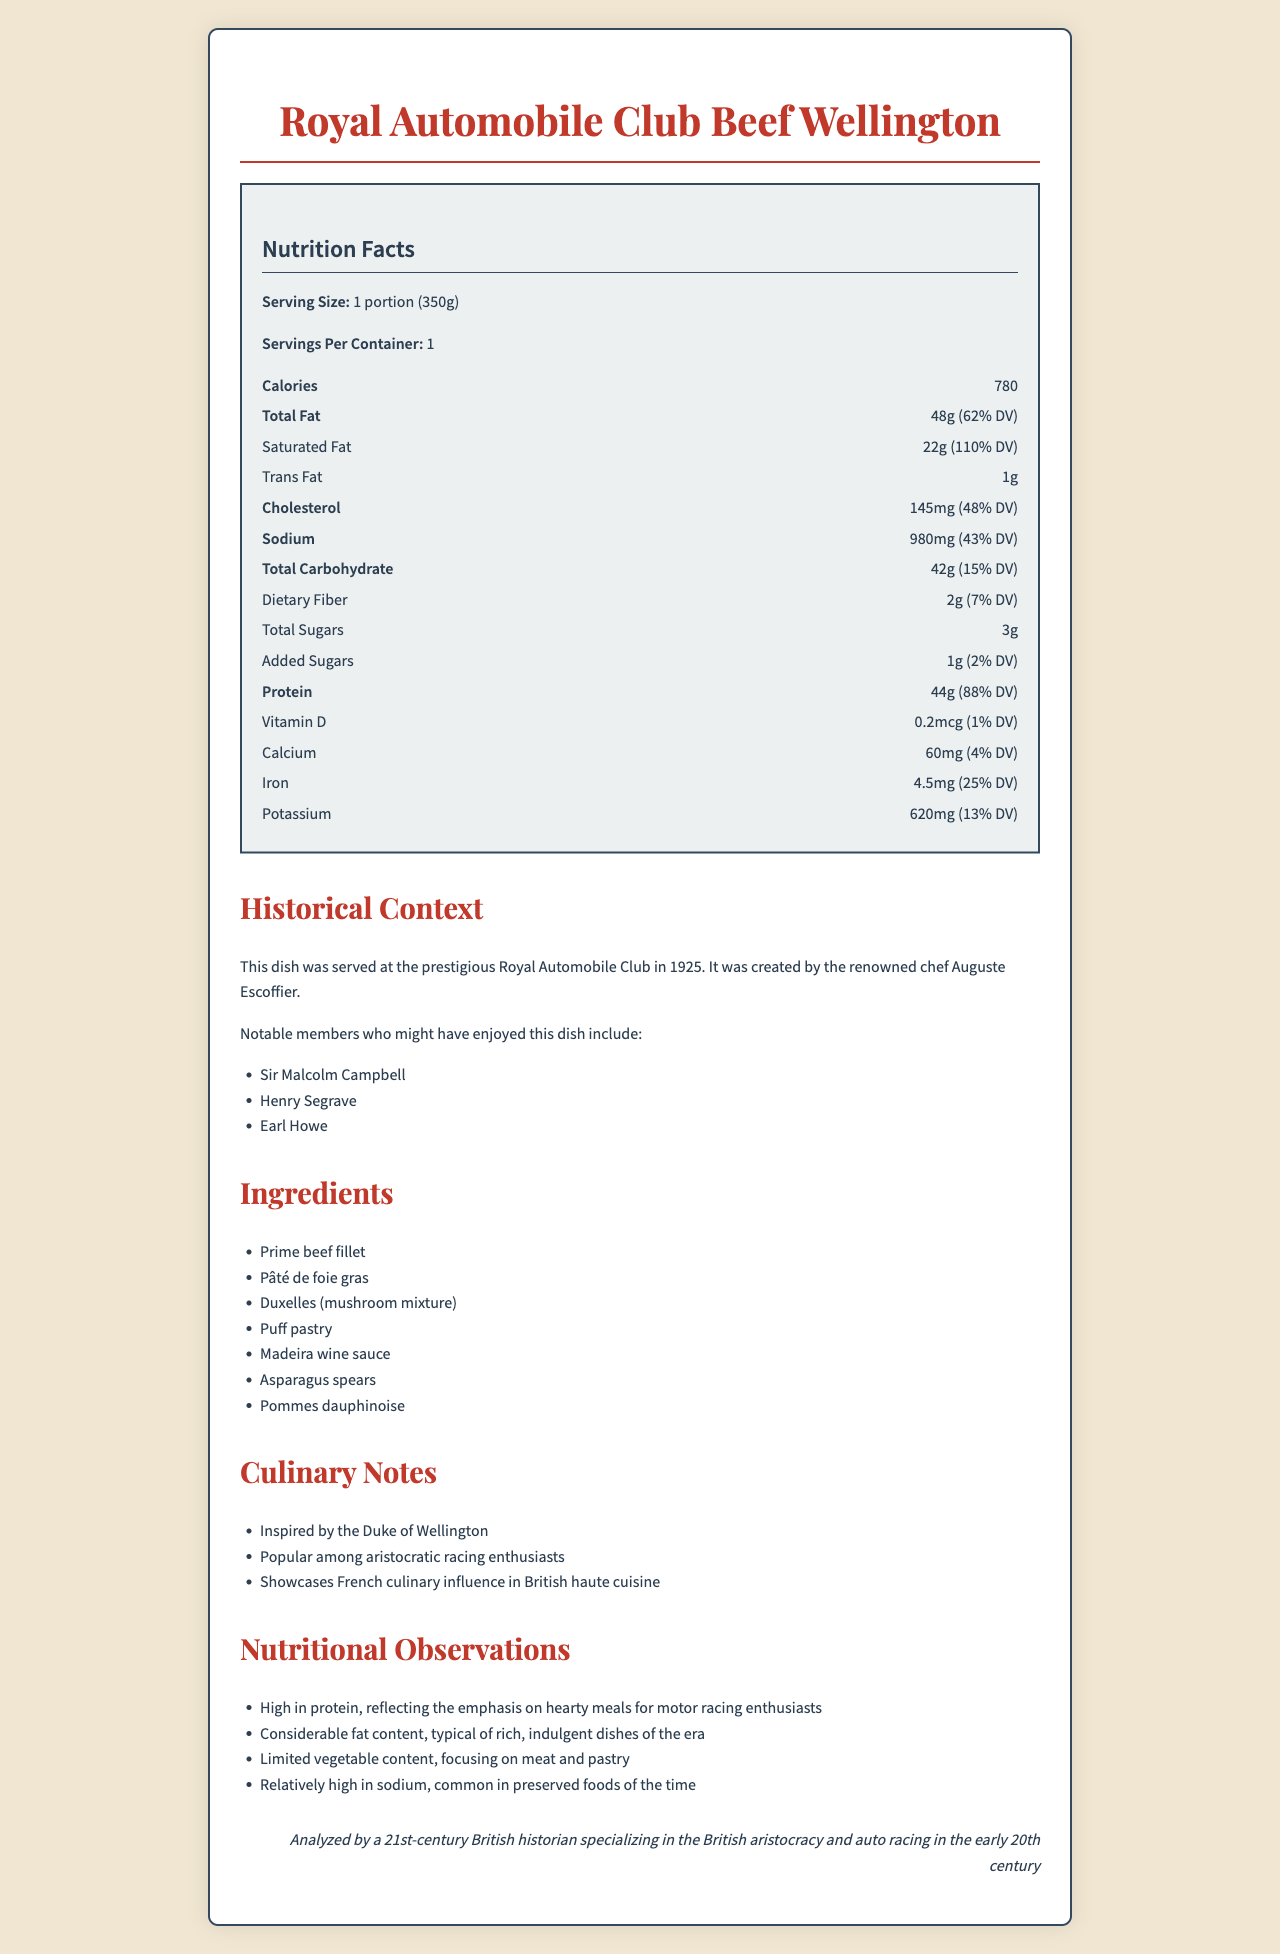How many calories are in one portion of the Royal Automobile Club Beef Wellington? The document directly lists the calorie content as 780 calories per one portion serving size of 350g.
Answer: 780 What is the serving size for the Beef Wellington? The document explicitly states the serving size as 1 portion (350g).
Answer: 1 portion (350g) What percentage of the daily value for saturated fat does this dish provide? The document specifies that the saturated fat daily value percentage is 110%.
Answer: 110% Who was the chef who created this dish? Under the Historical Context section, the document states that the dish was created by the renowned chef Auguste Escoffier.
Answer: Auguste Escoffier What is the amount of protein in the Beef Wellington? The nutritional label section reports that one portion contains 44g of protein.
Answer: 44g Who were some notable members of the Royal Automobile Club who might have enjoyed this dish? The Historical Context lists these three as notable members.
Answer: Sir Malcolm Campbell, Henry Segrave, Earl Howe What is the main source of the high fat content in this dish? A. Puff pastry B. Prime beef fillet C. Pâté de foie gras D. Duxelles Pâté de foie gras is known for its high fat content, which contributes largely to the overall fat content in the dish.
Answer: C. Pâté de foie gras What notable culinary influence does this dish showcase? A. British B. French C. Italian D. Spanish The Culinary Notes section indicates that the dish showcases French culinary influence in British haute cuisine.
Answer: B. French Is the content of dietary fiber in the Beef Wellington high? The document states that the dietary fiber content is 2g, which is relatively low and accounts for only 7% of the daily value.
Answer: No Summarize the nutritional observations provided in this document. This is a summary of the nutritional observations section.
Answer: The dish is high in protein and fat, reflecting the hearty meals favored by motor racing enthusiasts. It has considerable fat content, typical of rich, indulgent dishes of the era, with limited vegetable content focusing on meat and pastry. Sodium content is high, consistent with the common preserved foods of the time. Was the Beef Wellington named after any historical figure? The culinary note specifies that the dish is inspired by the Duke of Wellington, indicating it is named after a historical figure.
Answer: Yes What year was the Royal Automobile Club Beef Wellington served? The Historical Context section specifies that the dish was served in the year 1925.
Answer: 1925 Which of the following ingredients is not listed as part of the Beef Wellington? A. Bacon B. Madeira wine sauce C. Asparagus spears D. Puff pastry Bacon is not listed in the ingredients section, while Madeira wine sauce, Asparagus spears, and Puff pastry are included.
Answer: A. Bacon The Beef Wellington contains which kind of pastry? The ingredients section mentions that puff pastry is a part of the dish.
Answer: Puff pastry How many milligrams of potassium does the Beef Wellington contain? The nutritional label lists the potassium content as 620mg.
Answer: 620mg What is the purpose of the Madeira wine sauce in the dish? The document lists Madeira wine sauce as an ingredient but does not provide specific information on its purpose in the dish.
Answer: Cannot be determined What is the nutritional value's daily percentage for added sugars? The nutritional label indicates that added sugars make up 2% of the daily value.
Answer: 2% Where was this dish served? The Historical Context specifies that the dish was served at the Royal Automobile Club.
Answer: Royal Automobile Club What type of meal does the Beef Wellington reflect the emphasis on? The nutritional observations point out that the high protein content reflects the emphasis on hearty meals for motor racing enthusiasts.
Answer: Hearty meals for motor racing enthusiasts 